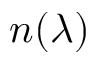<formula> <loc_0><loc_0><loc_500><loc_500>n ( \lambda )</formula> 